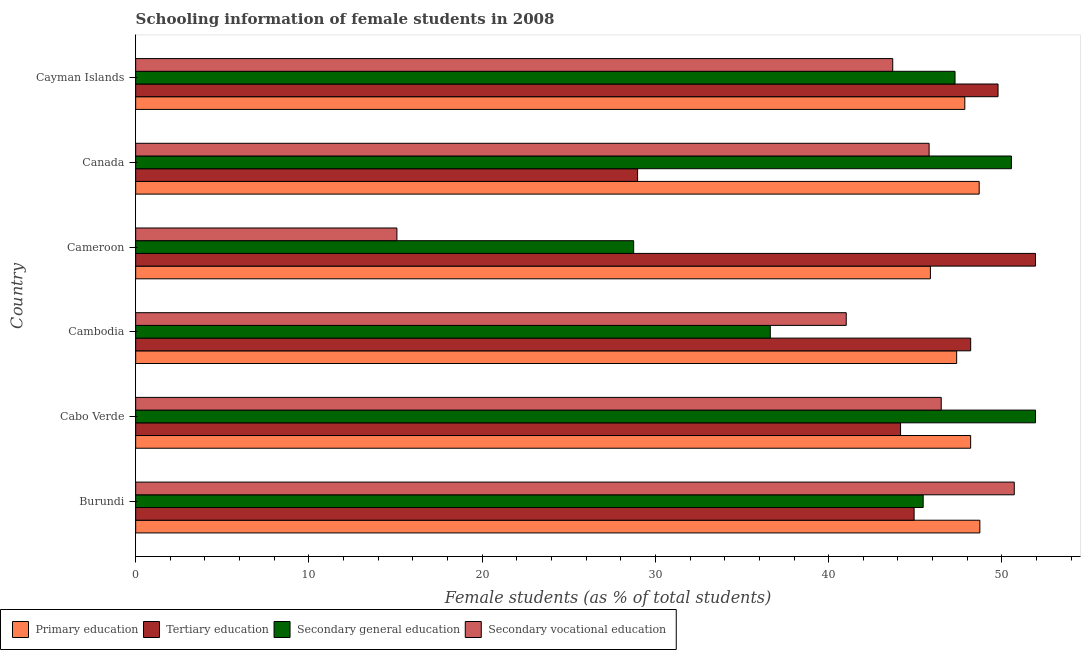How many groups of bars are there?
Your answer should be compact. 6. Are the number of bars per tick equal to the number of legend labels?
Provide a short and direct response. Yes. How many bars are there on the 1st tick from the top?
Make the answer very short. 4. How many bars are there on the 5th tick from the bottom?
Keep it short and to the point. 4. What is the label of the 3rd group of bars from the top?
Make the answer very short. Cameroon. What is the percentage of female students in primary education in Canada?
Provide a succinct answer. 48.69. Across all countries, what is the maximum percentage of female students in secondary education?
Offer a terse response. 51.94. Across all countries, what is the minimum percentage of female students in secondary education?
Offer a terse response. 28.74. In which country was the percentage of female students in secondary education maximum?
Your answer should be very brief. Cabo Verde. In which country was the percentage of female students in tertiary education minimum?
Offer a terse response. Canada. What is the total percentage of female students in tertiary education in the graph?
Offer a very short reply. 267.96. What is the difference between the percentage of female students in primary education in Cameroon and the percentage of female students in secondary education in Cabo Verde?
Your answer should be compact. -6.07. What is the average percentage of female students in tertiary education per country?
Your response must be concise. 44.66. What is the difference between the percentage of female students in secondary vocational education and percentage of female students in secondary education in Cabo Verde?
Your answer should be very brief. -5.44. What is the ratio of the percentage of female students in secondary vocational education in Canada to that in Cayman Islands?
Make the answer very short. 1.05. Is the percentage of female students in tertiary education in Burundi less than that in Cayman Islands?
Offer a very short reply. Yes. What is the difference between the highest and the second highest percentage of female students in secondary education?
Provide a short and direct response. 1.39. What is the difference between the highest and the lowest percentage of female students in secondary education?
Your answer should be compact. 23.19. In how many countries, is the percentage of female students in secondary vocational education greater than the average percentage of female students in secondary vocational education taken over all countries?
Provide a short and direct response. 5. What does the 4th bar from the top in Cabo Verde represents?
Offer a terse response. Primary education. What does the 3rd bar from the bottom in Cabo Verde represents?
Give a very brief answer. Secondary general education. Are all the bars in the graph horizontal?
Your answer should be very brief. Yes. What is the difference between two consecutive major ticks on the X-axis?
Your answer should be compact. 10. Where does the legend appear in the graph?
Your answer should be very brief. Bottom left. How are the legend labels stacked?
Provide a succinct answer. Horizontal. What is the title of the graph?
Ensure brevity in your answer.  Schooling information of female students in 2008. Does "Goods and services" appear as one of the legend labels in the graph?
Provide a short and direct response. No. What is the label or title of the X-axis?
Your response must be concise. Female students (as % of total students). What is the label or title of the Y-axis?
Make the answer very short. Country. What is the Female students (as % of total students) of Primary education in Burundi?
Make the answer very short. 48.73. What is the Female students (as % of total students) in Tertiary education in Burundi?
Offer a very short reply. 44.93. What is the Female students (as % of total students) of Secondary general education in Burundi?
Your answer should be very brief. 45.46. What is the Female students (as % of total students) in Secondary vocational education in Burundi?
Your response must be concise. 50.71. What is the Female students (as % of total students) of Primary education in Cabo Verde?
Offer a very short reply. 48.2. What is the Female students (as % of total students) of Tertiary education in Cabo Verde?
Your answer should be very brief. 44.15. What is the Female students (as % of total students) of Secondary general education in Cabo Verde?
Keep it short and to the point. 51.94. What is the Female students (as % of total students) of Secondary vocational education in Cabo Verde?
Your response must be concise. 46.5. What is the Female students (as % of total students) of Primary education in Cambodia?
Keep it short and to the point. 47.39. What is the Female students (as % of total students) of Tertiary education in Cambodia?
Make the answer very short. 48.2. What is the Female students (as % of total students) of Secondary general education in Cambodia?
Make the answer very short. 36.63. What is the Female students (as % of total students) in Secondary vocational education in Cambodia?
Your response must be concise. 41.01. What is the Female students (as % of total students) of Primary education in Cameroon?
Make the answer very short. 45.87. What is the Female students (as % of total students) in Tertiary education in Cameroon?
Make the answer very short. 51.94. What is the Female students (as % of total students) of Secondary general education in Cameroon?
Your response must be concise. 28.74. What is the Female students (as % of total students) of Secondary vocational education in Cameroon?
Keep it short and to the point. 15.08. What is the Female students (as % of total students) of Primary education in Canada?
Your response must be concise. 48.69. What is the Female students (as % of total students) of Tertiary education in Canada?
Your response must be concise. 28.97. What is the Female students (as % of total students) in Secondary general education in Canada?
Provide a short and direct response. 50.55. What is the Female students (as % of total students) of Secondary vocational education in Canada?
Provide a succinct answer. 45.8. What is the Female students (as % of total students) in Primary education in Cayman Islands?
Offer a very short reply. 47.86. What is the Female students (as % of total students) of Tertiary education in Cayman Islands?
Your response must be concise. 49.78. What is the Female students (as % of total students) of Secondary general education in Cayman Islands?
Your answer should be compact. 47.29. What is the Female students (as % of total students) in Secondary vocational education in Cayman Islands?
Give a very brief answer. 43.7. Across all countries, what is the maximum Female students (as % of total students) of Primary education?
Your answer should be very brief. 48.73. Across all countries, what is the maximum Female students (as % of total students) of Tertiary education?
Make the answer very short. 51.94. Across all countries, what is the maximum Female students (as % of total students) in Secondary general education?
Make the answer very short. 51.94. Across all countries, what is the maximum Female students (as % of total students) of Secondary vocational education?
Keep it short and to the point. 50.71. Across all countries, what is the minimum Female students (as % of total students) in Primary education?
Your response must be concise. 45.87. Across all countries, what is the minimum Female students (as % of total students) in Tertiary education?
Make the answer very short. 28.97. Across all countries, what is the minimum Female students (as % of total students) of Secondary general education?
Ensure brevity in your answer.  28.74. Across all countries, what is the minimum Female students (as % of total students) in Secondary vocational education?
Offer a terse response. 15.08. What is the total Female students (as % of total students) in Primary education in the graph?
Ensure brevity in your answer.  286.73. What is the total Female students (as % of total students) in Tertiary education in the graph?
Keep it short and to the point. 267.96. What is the total Female students (as % of total students) in Secondary general education in the graph?
Provide a succinct answer. 260.61. What is the total Female students (as % of total students) of Secondary vocational education in the graph?
Offer a very short reply. 242.8. What is the difference between the Female students (as % of total students) of Primary education in Burundi and that in Cabo Verde?
Provide a succinct answer. 0.53. What is the difference between the Female students (as % of total students) of Tertiary education in Burundi and that in Cabo Verde?
Your answer should be compact. 0.78. What is the difference between the Female students (as % of total students) in Secondary general education in Burundi and that in Cabo Verde?
Make the answer very short. -6.48. What is the difference between the Female students (as % of total students) in Secondary vocational education in Burundi and that in Cabo Verde?
Keep it short and to the point. 4.22. What is the difference between the Female students (as % of total students) in Primary education in Burundi and that in Cambodia?
Offer a very short reply. 1.34. What is the difference between the Female students (as % of total students) of Tertiary education in Burundi and that in Cambodia?
Provide a succinct answer. -3.27. What is the difference between the Female students (as % of total students) in Secondary general education in Burundi and that in Cambodia?
Provide a succinct answer. 8.82. What is the difference between the Female students (as % of total students) of Secondary vocational education in Burundi and that in Cambodia?
Provide a succinct answer. 9.7. What is the difference between the Female students (as % of total students) in Primary education in Burundi and that in Cameroon?
Keep it short and to the point. 2.85. What is the difference between the Female students (as % of total students) in Tertiary education in Burundi and that in Cameroon?
Ensure brevity in your answer.  -7.01. What is the difference between the Female students (as % of total students) in Secondary general education in Burundi and that in Cameroon?
Keep it short and to the point. 16.71. What is the difference between the Female students (as % of total students) of Secondary vocational education in Burundi and that in Cameroon?
Offer a very short reply. 35.63. What is the difference between the Female students (as % of total students) in Primary education in Burundi and that in Canada?
Make the answer very short. 0.04. What is the difference between the Female students (as % of total students) of Tertiary education in Burundi and that in Canada?
Offer a very short reply. 15.96. What is the difference between the Female students (as % of total students) of Secondary general education in Burundi and that in Canada?
Make the answer very short. -5.09. What is the difference between the Female students (as % of total students) of Secondary vocational education in Burundi and that in Canada?
Provide a short and direct response. 4.92. What is the difference between the Female students (as % of total students) in Primary education in Burundi and that in Cayman Islands?
Your answer should be compact. 0.87. What is the difference between the Female students (as % of total students) in Tertiary education in Burundi and that in Cayman Islands?
Your answer should be compact. -4.85. What is the difference between the Female students (as % of total students) of Secondary general education in Burundi and that in Cayman Islands?
Offer a very short reply. -1.84. What is the difference between the Female students (as % of total students) of Secondary vocational education in Burundi and that in Cayman Islands?
Give a very brief answer. 7.02. What is the difference between the Female students (as % of total students) of Primary education in Cabo Verde and that in Cambodia?
Your response must be concise. 0.81. What is the difference between the Female students (as % of total students) of Tertiary education in Cabo Verde and that in Cambodia?
Offer a terse response. -4.05. What is the difference between the Female students (as % of total students) of Secondary general education in Cabo Verde and that in Cambodia?
Keep it short and to the point. 15.31. What is the difference between the Female students (as % of total students) in Secondary vocational education in Cabo Verde and that in Cambodia?
Give a very brief answer. 5.48. What is the difference between the Female students (as % of total students) of Primary education in Cabo Verde and that in Cameroon?
Provide a short and direct response. 2.32. What is the difference between the Female students (as % of total students) of Tertiary education in Cabo Verde and that in Cameroon?
Provide a short and direct response. -7.79. What is the difference between the Female students (as % of total students) of Secondary general education in Cabo Verde and that in Cameroon?
Keep it short and to the point. 23.2. What is the difference between the Female students (as % of total students) in Secondary vocational education in Cabo Verde and that in Cameroon?
Your answer should be compact. 31.42. What is the difference between the Female students (as % of total students) in Primary education in Cabo Verde and that in Canada?
Make the answer very short. -0.49. What is the difference between the Female students (as % of total students) of Tertiary education in Cabo Verde and that in Canada?
Offer a very short reply. 15.18. What is the difference between the Female students (as % of total students) in Secondary general education in Cabo Verde and that in Canada?
Provide a short and direct response. 1.39. What is the difference between the Female students (as % of total students) of Secondary vocational education in Cabo Verde and that in Canada?
Give a very brief answer. 0.7. What is the difference between the Female students (as % of total students) of Primary education in Cabo Verde and that in Cayman Islands?
Offer a very short reply. 0.34. What is the difference between the Female students (as % of total students) in Tertiary education in Cabo Verde and that in Cayman Islands?
Keep it short and to the point. -5.63. What is the difference between the Female students (as % of total students) of Secondary general education in Cabo Verde and that in Cayman Islands?
Offer a terse response. 4.64. What is the difference between the Female students (as % of total students) in Secondary vocational education in Cabo Verde and that in Cayman Islands?
Make the answer very short. 2.8. What is the difference between the Female students (as % of total students) of Primary education in Cambodia and that in Cameroon?
Your answer should be very brief. 1.51. What is the difference between the Female students (as % of total students) of Tertiary education in Cambodia and that in Cameroon?
Give a very brief answer. -3.74. What is the difference between the Female students (as % of total students) of Secondary general education in Cambodia and that in Cameroon?
Ensure brevity in your answer.  7.89. What is the difference between the Female students (as % of total students) of Secondary vocational education in Cambodia and that in Cameroon?
Your response must be concise. 25.93. What is the difference between the Female students (as % of total students) in Primary education in Cambodia and that in Canada?
Your answer should be very brief. -1.3. What is the difference between the Female students (as % of total students) of Tertiary education in Cambodia and that in Canada?
Offer a terse response. 19.23. What is the difference between the Female students (as % of total students) of Secondary general education in Cambodia and that in Canada?
Keep it short and to the point. -13.92. What is the difference between the Female students (as % of total students) in Secondary vocational education in Cambodia and that in Canada?
Make the answer very short. -4.78. What is the difference between the Female students (as % of total students) of Primary education in Cambodia and that in Cayman Islands?
Make the answer very short. -0.47. What is the difference between the Female students (as % of total students) of Tertiary education in Cambodia and that in Cayman Islands?
Give a very brief answer. -1.58. What is the difference between the Female students (as % of total students) in Secondary general education in Cambodia and that in Cayman Islands?
Your answer should be very brief. -10.66. What is the difference between the Female students (as % of total students) of Secondary vocational education in Cambodia and that in Cayman Islands?
Your answer should be compact. -2.68. What is the difference between the Female students (as % of total students) of Primary education in Cameroon and that in Canada?
Provide a short and direct response. -2.82. What is the difference between the Female students (as % of total students) of Tertiary education in Cameroon and that in Canada?
Ensure brevity in your answer.  22.97. What is the difference between the Female students (as % of total students) in Secondary general education in Cameroon and that in Canada?
Keep it short and to the point. -21.81. What is the difference between the Female students (as % of total students) in Secondary vocational education in Cameroon and that in Canada?
Give a very brief answer. -30.72. What is the difference between the Female students (as % of total students) in Primary education in Cameroon and that in Cayman Islands?
Your answer should be very brief. -1.99. What is the difference between the Female students (as % of total students) of Tertiary education in Cameroon and that in Cayman Islands?
Your answer should be compact. 2.16. What is the difference between the Female students (as % of total students) of Secondary general education in Cameroon and that in Cayman Islands?
Provide a short and direct response. -18.55. What is the difference between the Female students (as % of total students) of Secondary vocational education in Cameroon and that in Cayman Islands?
Provide a short and direct response. -28.62. What is the difference between the Female students (as % of total students) in Primary education in Canada and that in Cayman Islands?
Your answer should be compact. 0.83. What is the difference between the Female students (as % of total students) in Tertiary education in Canada and that in Cayman Islands?
Your answer should be compact. -20.81. What is the difference between the Female students (as % of total students) in Secondary general education in Canada and that in Cayman Islands?
Keep it short and to the point. 3.25. What is the difference between the Female students (as % of total students) of Secondary vocational education in Canada and that in Cayman Islands?
Provide a short and direct response. 2.1. What is the difference between the Female students (as % of total students) of Primary education in Burundi and the Female students (as % of total students) of Tertiary education in Cabo Verde?
Ensure brevity in your answer.  4.58. What is the difference between the Female students (as % of total students) of Primary education in Burundi and the Female students (as % of total students) of Secondary general education in Cabo Verde?
Offer a terse response. -3.21. What is the difference between the Female students (as % of total students) of Primary education in Burundi and the Female students (as % of total students) of Secondary vocational education in Cabo Verde?
Your answer should be very brief. 2.23. What is the difference between the Female students (as % of total students) of Tertiary education in Burundi and the Female students (as % of total students) of Secondary general education in Cabo Verde?
Provide a short and direct response. -7.01. What is the difference between the Female students (as % of total students) in Tertiary education in Burundi and the Female students (as % of total students) in Secondary vocational education in Cabo Verde?
Keep it short and to the point. -1.57. What is the difference between the Female students (as % of total students) in Secondary general education in Burundi and the Female students (as % of total students) in Secondary vocational education in Cabo Verde?
Make the answer very short. -1.04. What is the difference between the Female students (as % of total students) of Primary education in Burundi and the Female students (as % of total students) of Tertiary education in Cambodia?
Keep it short and to the point. 0.53. What is the difference between the Female students (as % of total students) of Primary education in Burundi and the Female students (as % of total students) of Secondary general education in Cambodia?
Ensure brevity in your answer.  12.1. What is the difference between the Female students (as % of total students) in Primary education in Burundi and the Female students (as % of total students) in Secondary vocational education in Cambodia?
Your answer should be very brief. 7.71. What is the difference between the Female students (as % of total students) of Tertiary education in Burundi and the Female students (as % of total students) of Secondary general education in Cambodia?
Offer a very short reply. 8.3. What is the difference between the Female students (as % of total students) in Tertiary education in Burundi and the Female students (as % of total students) in Secondary vocational education in Cambodia?
Offer a terse response. 3.92. What is the difference between the Female students (as % of total students) of Secondary general education in Burundi and the Female students (as % of total students) of Secondary vocational education in Cambodia?
Keep it short and to the point. 4.44. What is the difference between the Female students (as % of total students) in Primary education in Burundi and the Female students (as % of total students) in Tertiary education in Cameroon?
Provide a short and direct response. -3.21. What is the difference between the Female students (as % of total students) of Primary education in Burundi and the Female students (as % of total students) of Secondary general education in Cameroon?
Provide a short and direct response. 19.98. What is the difference between the Female students (as % of total students) of Primary education in Burundi and the Female students (as % of total students) of Secondary vocational education in Cameroon?
Ensure brevity in your answer.  33.65. What is the difference between the Female students (as % of total students) in Tertiary education in Burundi and the Female students (as % of total students) in Secondary general education in Cameroon?
Your answer should be very brief. 16.19. What is the difference between the Female students (as % of total students) of Tertiary education in Burundi and the Female students (as % of total students) of Secondary vocational education in Cameroon?
Give a very brief answer. 29.85. What is the difference between the Female students (as % of total students) of Secondary general education in Burundi and the Female students (as % of total students) of Secondary vocational education in Cameroon?
Keep it short and to the point. 30.38. What is the difference between the Female students (as % of total students) in Primary education in Burundi and the Female students (as % of total students) in Tertiary education in Canada?
Make the answer very short. 19.76. What is the difference between the Female students (as % of total students) of Primary education in Burundi and the Female students (as % of total students) of Secondary general education in Canada?
Keep it short and to the point. -1.82. What is the difference between the Female students (as % of total students) in Primary education in Burundi and the Female students (as % of total students) in Secondary vocational education in Canada?
Your answer should be compact. 2.93. What is the difference between the Female students (as % of total students) of Tertiary education in Burundi and the Female students (as % of total students) of Secondary general education in Canada?
Provide a short and direct response. -5.62. What is the difference between the Female students (as % of total students) in Tertiary education in Burundi and the Female students (as % of total students) in Secondary vocational education in Canada?
Offer a terse response. -0.87. What is the difference between the Female students (as % of total students) in Secondary general education in Burundi and the Female students (as % of total students) in Secondary vocational education in Canada?
Offer a very short reply. -0.34. What is the difference between the Female students (as % of total students) in Primary education in Burundi and the Female students (as % of total students) in Tertiary education in Cayman Islands?
Offer a terse response. -1.05. What is the difference between the Female students (as % of total students) of Primary education in Burundi and the Female students (as % of total students) of Secondary general education in Cayman Islands?
Your response must be concise. 1.43. What is the difference between the Female students (as % of total students) in Primary education in Burundi and the Female students (as % of total students) in Secondary vocational education in Cayman Islands?
Give a very brief answer. 5.03. What is the difference between the Female students (as % of total students) in Tertiary education in Burundi and the Female students (as % of total students) in Secondary general education in Cayman Islands?
Provide a succinct answer. -2.36. What is the difference between the Female students (as % of total students) of Tertiary education in Burundi and the Female students (as % of total students) of Secondary vocational education in Cayman Islands?
Provide a short and direct response. 1.23. What is the difference between the Female students (as % of total students) in Secondary general education in Burundi and the Female students (as % of total students) in Secondary vocational education in Cayman Islands?
Make the answer very short. 1.76. What is the difference between the Female students (as % of total students) in Primary education in Cabo Verde and the Female students (as % of total students) in Tertiary education in Cambodia?
Your answer should be compact. -0. What is the difference between the Female students (as % of total students) of Primary education in Cabo Verde and the Female students (as % of total students) of Secondary general education in Cambodia?
Offer a terse response. 11.57. What is the difference between the Female students (as % of total students) of Primary education in Cabo Verde and the Female students (as % of total students) of Secondary vocational education in Cambodia?
Keep it short and to the point. 7.18. What is the difference between the Female students (as % of total students) in Tertiary education in Cabo Verde and the Female students (as % of total students) in Secondary general education in Cambodia?
Offer a very short reply. 7.52. What is the difference between the Female students (as % of total students) of Tertiary education in Cabo Verde and the Female students (as % of total students) of Secondary vocational education in Cambodia?
Your answer should be compact. 3.14. What is the difference between the Female students (as % of total students) in Secondary general education in Cabo Verde and the Female students (as % of total students) in Secondary vocational education in Cambodia?
Give a very brief answer. 10.92. What is the difference between the Female students (as % of total students) in Primary education in Cabo Verde and the Female students (as % of total students) in Tertiary education in Cameroon?
Offer a terse response. -3.74. What is the difference between the Female students (as % of total students) in Primary education in Cabo Verde and the Female students (as % of total students) in Secondary general education in Cameroon?
Your response must be concise. 19.45. What is the difference between the Female students (as % of total students) of Primary education in Cabo Verde and the Female students (as % of total students) of Secondary vocational education in Cameroon?
Ensure brevity in your answer.  33.12. What is the difference between the Female students (as % of total students) in Tertiary education in Cabo Verde and the Female students (as % of total students) in Secondary general education in Cameroon?
Give a very brief answer. 15.41. What is the difference between the Female students (as % of total students) of Tertiary education in Cabo Verde and the Female students (as % of total students) of Secondary vocational education in Cameroon?
Your answer should be compact. 29.07. What is the difference between the Female students (as % of total students) of Secondary general education in Cabo Verde and the Female students (as % of total students) of Secondary vocational education in Cameroon?
Ensure brevity in your answer.  36.86. What is the difference between the Female students (as % of total students) in Primary education in Cabo Verde and the Female students (as % of total students) in Tertiary education in Canada?
Your answer should be compact. 19.23. What is the difference between the Female students (as % of total students) in Primary education in Cabo Verde and the Female students (as % of total students) in Secondary general education in Canada?
Your answer should be compact. -2.35. What is the difference between the Female students (as % of total students) in Primary education in Cabo Verde and the Female students (as % of total students) in Secondary vocational education in Canada?
Ensure brevity in your answer.  2.4. What is the difference between the Female students (as % of total students) in Tertiary education in Cabo Verde and the Female students (as % of total students) in Secondary general education in Canada?
Keep it short and to the point. -6.4. What is the difference between the Female students (as % of total students) in Tertiary education in Cabo Verde and the Female students (as % of total students) in Secondary vocational education in Canada?
Keep it short and to the point. -1.65. What is the difference between the Female students (as % of total students) in Secondary general education in Cabo Verde and the Female students (as % of total students) in Secondary vocational education in Canada?
Provide a short and direct response. 6.14. What is the difference between the Female students (as % of total students) of Primary education in Cabo Verde and the Female students (as % of total students) of Tertiary education in Cayman Islands?
Your answer should be compact. -1.58. What is the difference between the Female students (as % of total students) in Primary education in Cabo Verde and the Female students (as % of total students) in Secondary general education in Cayman Islands?
Ensure brevity in your answer.  0.9. What is the difference between the Female students (as % of total students) in Primary education in Cabo Verde and the Female students (as % of total students) in Secondary vocational education in Cayman Islands?
Ensure brevity in your answer.  4.5. What is the difference between the Female students (as % of total students) in Tertiary education in Cabo Verde and the Female students (as % of total students) in Secondary general education in Cayman Islands?
Give a very brief answer. -3.14. What is the difference between the Female students (as % of total students) of Tertiary education in Cabo Verde and the Female students (as % of total students) of Secondary vocational education in Cayman Islands?
Ensure brevity in your answer.  0.45. What is the difference between the Female students (as % of total students) of Secondary general education in Cabo Verde and the Female students (as % of total students) of Secondary vocational education in Cayman Islands?
Keep it short and to the point. 8.24. What is the difference between the Female students (as % of total students) of Primary education in Cambodia and the Female students (as % of total students) of Tertiary education in Cameroon?
Your answer should be very brief. -4.55. What is the difference between the Female students (as % of total students) in Primary education in Cambodia and the Female students (as % of total students) in Secondary general education in Cameroon?
Keep it short and to the point. 18.64. What is the difference between the Female students (as % of total students) in Primary education in Cambodia and the Female students (as % of total students) in Secondary vocational education in Cameroon?
Your response must be concise. 32.31. What is the difference between the Female students (as % of total students) in Tertiary education in Cambodia and the Female students (as % of total students) in Secondary general education in Cameroon?
Offer a terse response. 19.45. What is the difference between the Female students (as % of total students) in Tertiary education in Cambodia and the Female students (as % of total students) in Secondary vocational education in Cameroon?
Ensure brevity in your answer.  33.12. What is the difference between the Female students (as % of total students) of Secondary general education in Cambodia and the Female students (as % of total students) of Secondary vocational education in Cameroon?
Ensure brevity in your answer.  21.55. What is the difference between the Female students (as % of total students) of Primary education in Cambodia and the Female students (as % of total students) of Tertiary education in Canada?
Give a very brief answer. 18.42. What is the difference between the Female students (as % of total students) of Primary education in Cambodia and the Female students (as % of total students) of Secondary general education in Canada?
Keep it short and to the point. -3.16. What is the difference between the Female students (as % of total students) in Primary education in Cambodia and the Female students (as % of total students) in Secondary vocational education in Canada?
Provide a short and direct response. 1.59. What is the difference between the Female students (as % of total students) of Tertiary education in Cambodia and the Female students (as % of total students) of Secondary general education in Canada?
Your response must be concise. -2.35. What is the difference between the Female students (as % of total students) of Tertiary education in Cambodia and the Female students (as % of total students) of Secondary vocational education in Canada?
Offer a very short reply. 2.4. What is the difference between the Female students (as % of total students) of Secondary general education in Cambodia and the Female students (as % of total students) of Secondary vocational education in Canada?
Give a very brief answer. -9.17. What is the difference between the Female students (as % of total students) of Primary education in Cambodia and the Female students (as % of total students) of Tertiary education in Cayman Islands?
Ensure brevity in your answer.  -2.39. What is the difference between the Female students (as % of total students) of Primary education in Cambodia and the Female students (as % of total students) of Secondary general education in Cayman Islands?
Keep it short and to the point. 0.09. What is the difference between the Female students (as % of total students) in Primary education in Cambodia and the Female students (as % of total students) in Secondary vocational education in Cayman Islands?
Your answer should be compact. 3.69. What is the difference between the Female students (as % of total students) in Tertiary education in Cambodia and the Female students (as % of total students) in Secondary general education in Cayman Islands?
Offer a terse response. 0.9. What is the difference between the Female students (as % of total students) of Tertiary education in Cambodia and the Female students (as % of total students) of Secondary vocational education in Cayman Islands?
Ensure brevity in your answer.  4.5. What is the difference between the Female students (as % of total students) of Secondary general education in Cambodia and the Female students (as % of total students) of Secondary vocational education in Cayman Islands?
Offer a terse response. -7.07. What is the difference between the Female students (as % of total students) in Primary education in Cameroon and the Female students (as % of total students) in Tertiary education in Canada?
Ensure brevity in your answer.  16.9. What is the difference between the Female students (as % of total students) of Primary education in Cameroon and the Female students (as % of total students) of Secondary general education in Canada?
Make the answer very short. -4.68. What is the difference between the Female students (as % of total students) in Primary education in Cameroon and the Female students (as % of total students) in Secondary vocational education in Canada?
Ensure brevity in your answer.  0.08. What is the difference between the Female students (as % of total students) of Tertiary education in Cameroon and the Female students (as % of total students) of Secondary general education in Canada?
Keep it short and to the point. 1.39. What is the difference between the Female students (as % of total students) of Tertiary education in Cameroon and the Female students (as % of total students) of Secondary vocational education in Canada?
Offer a terse response. 6.14. What is the difference between the Female students (as % of total students) of Secondary general education in Cameroon and the Female students (as % of total students) of Secondary vocational education in Canada?
Your response must be concise. -17.05. What is the difference between the Female students (as % of total students) in Primary education in Cameroon and the Female students (as % of total students) in Tertiary education in Cayman Islands?
Provide a short and direct response. -3.9. What is the difference between the Female students (as % of total students) in Primary education in Cameroon and the Female students (as % of total students) in Secondary general education in Cayman Islands?
Ensure brevity in your answer.  -1.42. What is the difference between the Female students (as % of total students) in Primary education in Cameroon and the Female students (as % of total students) in Secondary vocational education in Cayman Islands?
Your answer should be very brief. 2.17. What is the difference between the Female students (as % of total students) of Tertiary education in Cameroon and the Female students (as % of total students) of Secondary general education in Cayman Islands?
Your answer should be very brief. 4.64. What is the difference between the Female students (as % of total students) of Tertiary education in Cameroon and the Female students (as % of total students) of Secondary vocational education in Cayman Islands?
Offer a terse response. 8.24. What is the difference between the Female students (as % of total students) of Secondary general education in Cameroon and the Female students (as % of total students) of Secondary vocational education in Cayman Islands?
Give a very brief answer. -14.95. What is the difference between the Female students (as % of total students) in Primary education in Canada and the Female students (as % of total students) in Tertiary education in Cayman Islands?
Provide a short and direct response. -1.09. What is the difference between the Female students (as % of total students) of Primary education in Canada and the Female students (as % of total students) of Secondary general education in Cayman Islands?
Give a very brief answer. 1.39. What is the difference between the Female students (as % of total students) of Primary education in Canada and the Female students (as % of total students) of Secondary vocational education in Cayman Islands?
Ensure brevity in your answer.  4.99. What is the difference between the Female students (as % of total students) in Tertiary education in Canada and the Female students (as % of total students) in Secondary general education in Cayman Islands?
Keep it short and to the point. -18.32. What is the difference between the Female students (as % of total students) in Tertiary education in Canada and the Female students (as % of total students) in Secondary vocational education in Cayman Islands?
Ensure brevity in your answer.  -14.73. What is the difference between the Female students (as % of total students) in Secondary general education in Canada and the Female students (as % of total students) in Secondary vocational education in Cayman Islands?
Offer a terse response. 6.85. What is the average Female students (as % of total students) in Primary education per country?
Your answer should be very brief. 47.79. What is the average Female students (as % of total students) of Tertiary education per country?
Offer a terse response. 44.66. What is the average Female students (as % of total students) in Secondary general education per country?
Offer a terse response. 43.44. What is the average Female students (as % of total students) of Secondary vocational education per country?
Keep it short and to the point. 40.47. What is the difference between the Female students (as % of total students) of Primary education and Female students (as % of total students) of Tertiary education in Burundi?
Your response must be concise. 3.8. What is the difference between the Female students (as % of total students) of Primary education and Female students (as % of total students) of Secondary general education in Burundi?
Your response must be concise. 3.27. What is the difference between the Female students (as % of total students) of Primary education and Female students (as % of total students) of Secondary vocational education in Burundi?
Provide a succinct answer. -1.99. What is the difference between the Female students (as % of total students) of Tertiary education and Female students (as % of total students) of Secondary general education in Burundi?
Offer a very short reply. -0.52. What is the difference between the Female students (as % of total students) in Tertiary education and Female students (as % of total students) in Secondary vocational education in Burundi?
Provide a succinct answer. -5.78. What is the difference between the Female students (as % of total students) of Secondary general education and Female students (as % of total students) of Secondary vocational education in Burundi?
Provide a short and direct response. -5.26. What is the difference between the Female students (as % of total students) of Primary education and Female students (as % of total students) of Tertiary education in Cabo Verde?
Give a very brief answer. 4.05. What is the difference between the Female students (as % of total students) of Primary education and Female students (as % of total students) of Secondary general education in Cabo Verde?
Ensure brevity in your answer.  -3.74. What is the difference between the Female students (as % of total students) in Primary education and Female students (as % of total students) in Secondary vocational education in Cabo Verde?
Your answer should be compact. 1.7. What is the difference between the Female students (as % of total students) in Tertiary education and Female students (as % of total students) in Secondary general education in Cabo Verde?
Provide a short and direct response. -7.79. What is the difference between the Female students (as % of total students) in Tertiary education and Female students (as % of total students) in Secondary vocational education in Cabo Verde?
Make the answer very short. -2.35. What is the difference between the Female students (as % of total students) in Secondary general education and Female students (as % of total students) in Secondary vocational education in Cabo Verde?
Provide a succinct answer. 5.44. What is the difference between the Female students (as % of total students) of Primary education and Female students (as % of total students) of Tertiary education in Cambodia?
Your answer should be very brief. -0.81. What is the difference between the Female students (as % of total students) of Primary education and Female students (as % of total students) of Secondary general education in Cambodia?
Offer a terse response. 10.76. What is the difference between the Female students (as % of total students) in Primary education and Female students (as % of total students) in Secondary vocational education in Cambodia?
Offer a very short reply. 6.37. What is the difference between the Female students (as % of total students) of Tertiary education and Female students (as % of total students) of Secondary general education in Cambodia?
Keep it short and to the point. 11.57. What is the difference between the Female students (as % of total students) in Tertiary education and Female students (as % of total students) in Secondary vocational education in Cambodia?
Make the answer very short. 7.18. What is the difference between the Female students (as % of total students) of Secondary general education and Female students (as % of total students) of Secondary vocational education in Cambodia?
Your answer should be very brief. -4.38. What is the difference between the Female students (as % of total students) of Primary education and Female students (as % of total students) of Tertiary education in Cameroon?
Offer a very short reply. -6.07. What is the difference between the Female students (as % of total students) of Primary education and Female students (as % of total students) of Secondary general education in Cameroon?
Provide a succinct answer. 17.13. What is the difference between the Female students (as % of total students) of Primary education and Female students (as % of total students) of Secondary vocational education in Cameroon?
Offer a terse response. 30.79. What is the difference between the Female students (as % of total students) in Tertiary education and Female students (as % of total students) in Secondary general education in Cameroon?
Provide a succinct answer. 23.2. What is the difference between the Female students (as % of total students) of Tertiary education and Female students (as % of total students) of Secondary vocational education in Cameroon?
Provide a short and direct response. 36.86. What is the difference between the Female students (as % of total students) in Secondary general education and Female students (as % of total students) in Secondary vocational education in Cameroon?
Your response must be concise. 13.66. What is the difference between the Female students (as % of total students) of Primary education and Female students (as % of total students) of Tertiary education in Canada?
Offer a very short reply. 19.72. What is the difference between the Female students (as % of total students) of Primary education and Female students (as % of total students) of Secondary general education in Canada?
Offer a terse response. -1.86. What is the difference between the Female students (as % of total students) of Primary education and Female students (as % of total students) of Secondary vocational education in Canada?
Give a very brief answer. 2.89. What is the difference between the Female students (as % of total students) in Tertiary education and Female students (as % of total students) in Secondary general education in Canada?
Your answer should be compact. -21.58. What is the difference between the Female students (as % of total students) in Tertiary education and Female students (as % of total students) in Secondary vocational education in Canada?
Offer a terse response. -16.83. What is the difference between the Female students (as % of total students) of Secondary general education and Female students (as % of total students) of Secondary vocational education in Canada?
Your answer should be very brief. 4.75. What is the difference between the Female students (as % of total students) in Primary education and Female students (as % of total students) in Tertiary education in Cayman Islands?
Your answer should be very brief. -1.92. What is the difference between the Female students (as % of total students) of Primary education and Female students (as % of total students) of Secondary general education in Cayman Islands?
Offer a very short reply. 0.56. What is the difference between the Female students (as % of total students) of Primary education and Female students (as % of total students) of Secondary vocational education in Cayman Islands?
Provide a short and direct response. 4.16. What is the difference between the Female students (as % of total students) of Tertiary education and Female students (as % of total students) of Secondary general education in Cayman Islands?
Offer a very short reply. 2.48. What is the difference between the Female students (as % of total students) of Tertiary education and Female students (as % of total students) of Secondary vocational education in Cayman Islands?
Provide a short and direct response. 6.08. What is the difference between the Female students (as % of total students) in Secondary general education and Female students (as % of total students) in Secondary vocational education in Cayman Islands?
Give a very brief answer. 3.6. What is the ratio of the Female students (as % of total students) in Primary education in Burundi to that in Cabo Verde?
Your response must be concise. 1.01. What is the ratio of the Female students (as % of total students) in Tertiary education in Burundi to that in Cabo Verde?
Make the answer very short. 1.02. What is the ratio of the Female students (as % of total students) of Secondary general education in Burundi to that in Cabo Verde?
Offer a terse response. 0.88. What is the ratio of the Female students (as % of total students) of Secondary vocational education in Burundi to that in Cabo Verde?
Your answer should be compact. 1.09. What is the ratio of the Female students (as % of total students) of Primary education in Burundi to that in Cambodia?
Give a very brief answer. 1.03. What is the ratio of the Female students (as % of total students) in Tertiary education in Burundi to that in Cambodia?
Provide a succinct answer. 0.93. What is the ratio of the Female students (as % of total students) of Secondary general education in Burundi to that in Cambodia?
Give a very brief answer. 1.24. What is the ratio of the Female students (as % of total students) of Secondary vocational education in Burundi to that in Cambodia?
Offer a very short reply. 1.24. What is the ratio of the Female students (as % of total students) of Primary education in Burundi to that in Cameroon?
Your response must be concise. 1.06. What is the ratio of the Female students (as % of total students) in Tertiary education in Burundi to that in Cameroon?
Your response must be concise. 0.87. What is the ratio of the Female students (as % of total students) of Secondary general education in Burundi to that in Cameroon?
Provide a succinct answer. 1.58. What is the ratio of the Female students (as % of total students) in Secondary vocational education in Burundi to that in Cameroon?
Provide a short and direct response. 3.36. What is the ratio of the Female students (as % of total students) of Tertiary education in Burundi to that in Canada?
Your answer should be very brief. 1.55. What is the ratio of the Female students (as % of total students) in Secondary general education in Burundi to that in Canada?
Your answer should be very brief. 0.9. What is the ratio of the Female students (as % of total students) of Secondary vocational education in Burundi to that in Canada?
Your response must be concise. 1.11. What is the ratio of the Female students (as % of total students) in Primary education in Burundi to that in Cayman Islands?
Your answer should be very brief. 1.02. What is the ratio of the Female students (as % of total students) in Tertiary education in Burundi to that in Cayman Islands?
Your answer should be compact. 0.9. What is the ratio of the Female students (as % of total students) in Secondary general education in Burundi to that in Cayman Islands?
Keep it short and to the point. 0.96. What is the ratio of the Female students (as % of total students) in Secondary vocational education in Burundi to that in Cayman Islands?
Give a very brief answer. 1.16. What is the ratio of the Female students (as % of total students) in Primary education in Cabo Verde to that in Cambodia?
Provide a short and direct response. 1.02. What is the ratio of the Female students (as % of total students) in Tertiary education in Cabo Verde to that in Cambodia?
Provide a short and direct response. 0.92. What is the ratio of the Female students (as % of total students) in Secondary general education in Cabo Verde to that in Cambodia?
Keep it short and to the point. 1.42. What is the ratio of the Female students (as % of total students) in Secondary vocational education in Cabo Verde to that in Cambodia?
Your answer should be very brief. 1.13. What is the ratio of the Female students (as % of total students) of Primary education in Cabo Verde to that in Cameroon?
Your answer should be compact. 1.05. What is the ratio of the Female students (as % of total students) in Tertiary education in Cabo Verde to that in Cameroon?
Your answer should be very brief. 0.85. What is the ratio of the Female students (as % of total students) in Secondary general education in Cabo Verde to that in Cameroon?
Your answer should be compact. 1.81. What is the ratio of the Female students (as % of total students) in Secondary vocational education in Cabo Verde to that in Cameroon?
Give a very brief answer. 3.08. What is the ratio of the Female students (as % of total students) of Primary education in Cabo Verde to that in Canada?
Make the answer very short. 0.99. What is the ratio of the Female students (as % of total students) in Tertiary education in Cabo Verde to that in Canada?
Offer a terse response. 1.52. What is the ratio of the Female students (as % of total students) in Secondary general education in Cabo Verde to that in Canada?
Provide a short and direct response. 1.03. What is the ratio of the Female students (as % of total students) of Secondary vocational education in Cabo Verde to that in Canada?
Offer a terse response. 1.02. What is the ratio of the Female students (as % of total students) in Primary education in Cabo Verde to that in Cayman Islands?
Offer a very short reply. 1.01. What is the ratio of the Female students (as % of total students) of Tertiary education in Cabo Verde to that in Cayman Islands?
Your response must be concise. 0.89. What is the ratio of the Female students (as % of total students) in Secondary general education in Cabo Verde to that in Cayman Islands?
Your answer should be compact. 1.1. What is the ratio of the Female students (as % of total students) in Secondary vocational education in Cabo Verde to that in Cayman Islands?
Your answer should be very brief. 1.06. What is the ratio of the Female students (as % of total students) of Primary education in Cambodia to that in Cameroon?
Your answer should be compact. 1.03. What is the ratio of the Female students (as % of total students) of Tertiary education in Cambodia to that in Cameroon?
Make the answer very short. 0.93. What is the ratio of the Female students (as % of total students) of Secondary general education in Cambodia to that in Cameroon?
Ensure brevity in your answer.  1.27. What is the ratio of the Female students (as % of total students) of Secondary vocational education in Cambodia to that in Cameroon?
Provide a succinct answer. 2.72. What is the ratio of the Female students (as % of total students) in Primary education in Cambodia to that in Canada?
Make the answer very short. 0.97. What is the ratio of the Female students (as % of total students) in Tertiary education in Cambodia to that in Canada?
Your answer should be compact. 1.66. What is the ratio of the Female students (as % of total students) of Secondary general education in Cambodia to that in Canada?
Your answer should be compact. 0.72. What is the ratio of the Female students (as % of total students) of Secondary vocational education in Cambodia to that in Canada?
Ensure brevity in your answer.  0.9. What is the ratio of the Female students (as % of total students) of Primary education in Cambodia to that in Cayman Islands?
Ensure brevity in your answer.  0.99. What is the ratio of the Female students (as % of total students) of Tertiary education in Cambodia to that in Cayman Islands?
Give a very brief answer. 0.97. What is the ratio of the Female students (as % of total students) in Secondary general education in Cambodia to that in Cayman Islands?
Offer a very short reply. 0.77. What is the ratio of the Female students (as % of total students) of Secondary vocational education in Cambodia to that in Cayman Islands?
Keep it short and to the point. 0.94. What is the ratio of the Female students (as % of total students) of Primary education in Cameroon to that in Canada?
Your answer should be very brief. 0.94. What is the ratio of the Female students (as % of total students) of Tertiary education in Cameroon to that in Canada?
Provide a succinct answer. 1.79. What is the ratio of the Female students (as % of total students) in Secondary general education in Cameroon to that in Canada?
Ensure brevity in your answer.  0.57. What is the ratio of the Female students (as % of total students) of Secondary vocational education in Cameroon to that in Canada?
Give a very brief answer. 0.33. What is the ratio of the Female students (as % of total students) of Primary education in Cameroon to that in Cayman Islands?
Your answer should be very brief. 0.96. What is the ratio of the Female students (as % of total students) of Tertiary education in Cameroon to that in Cayman Islands?
Give a very brief answer. 1.04. What is the ratio of the Female students (as % of total students) in Secondary general education in Cameroon to that in Cayman Islands?
Make the answer very short. 0.61. What is the ratio of the Female students (as % of total students) in Secondary vocational education in Cameroon to that in Cayman Islands?
Give a very brief answer. 0.35. What is the ratio of the Female students (as % of total students) of Primary education in Canada to that in Cayman Islands?
Offer a terse response. 1.02. What is the ratio of the Female students (as % of total students) of Tertiary education in Canada to that in Cayman Islands?
Provide a short and direct response. 0.58. What is the ratio of the Female students (as % of total students) in Secondary general education in Canada to that in Cayman Islands?
Your answer should be compact. 1.07. What is the ratio of the Female students (as % of total students) of Secondary vocational education in Canada to that in Cayman Islands?
Provide a short and direct response. 1.05. What is the difference between the highest and the second highest Female students (as % of total students) in Primary education?
Provide a short and direct response. 0.04. What is the difference between the highest and the second highest Female students (as % of total students) in Tertiary education?
Your answer should be very brief. 2.16. What is the difference between the highest and the second highest Female students (as % of total students) of Secondary general education?
Give a very brief answer. 1.39. What is the difference between the highest and the second highest Female students (as % of total students) in Secondary vocational education?
Your answer should be compact. 4.22. What is the difference between the highest and the lowest Female students (as % of total students) in Primary education?
Offer a terse response. 2.85. What is the difference between the highest and the lowest Female students (as % of total students) of Tertiary education?
Offer a terse response. 22.97. What is the difference between the highest and the lowest Female students (as % of total students) in Secondary general education?
Offer a very short reply. 23.2. What is the difference between the highest and the lowest Female students (as % of total students) of Secondary vocational education?
Your response must be concise. 35.63. 